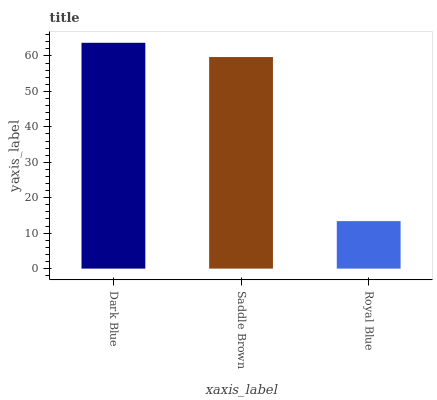Is Royal Blue the minimum?
Answer yes or no. Yes. Is Dark Blue the maximum?
Answer yes or no. Yes. Is Saddle Brown the minimum?
Answer yes or no. No. Is Saddle Brown the maximum?
Answer yes or no. No. Is Dark Blue greater than Saddle Brown?
Answer yes or no. Yes. Is Saddle Brown less than Dark Blue?
Answer yes or no. Yes. Is Saddle Brown greater than Dark Blue?
Answer yes or no. No. Is Dark Blue less than Saddle Brown?
Answer yes or no. No. Is Saddle Brown the high median?
Answer yes or no. Yes. Is Saddle Brown the low median?
Answer yes or no. Yes. Is Dark Blue the high median?
Answer yes or no. No. Is Dark Blue the low median?
Answer yes or no. No. 